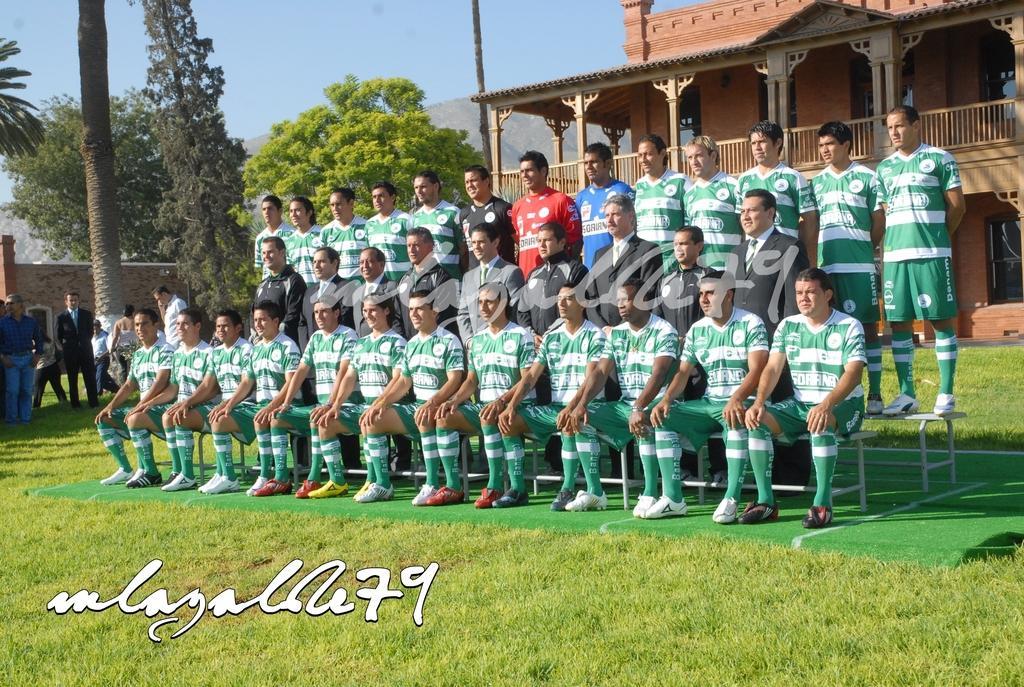Could you give a brief overview of what you see in this image? In this picture we can see a group of people on the ground and in the background we can see a building, trees, wall, mountain, sky and some objects, here we can see some text on it. 